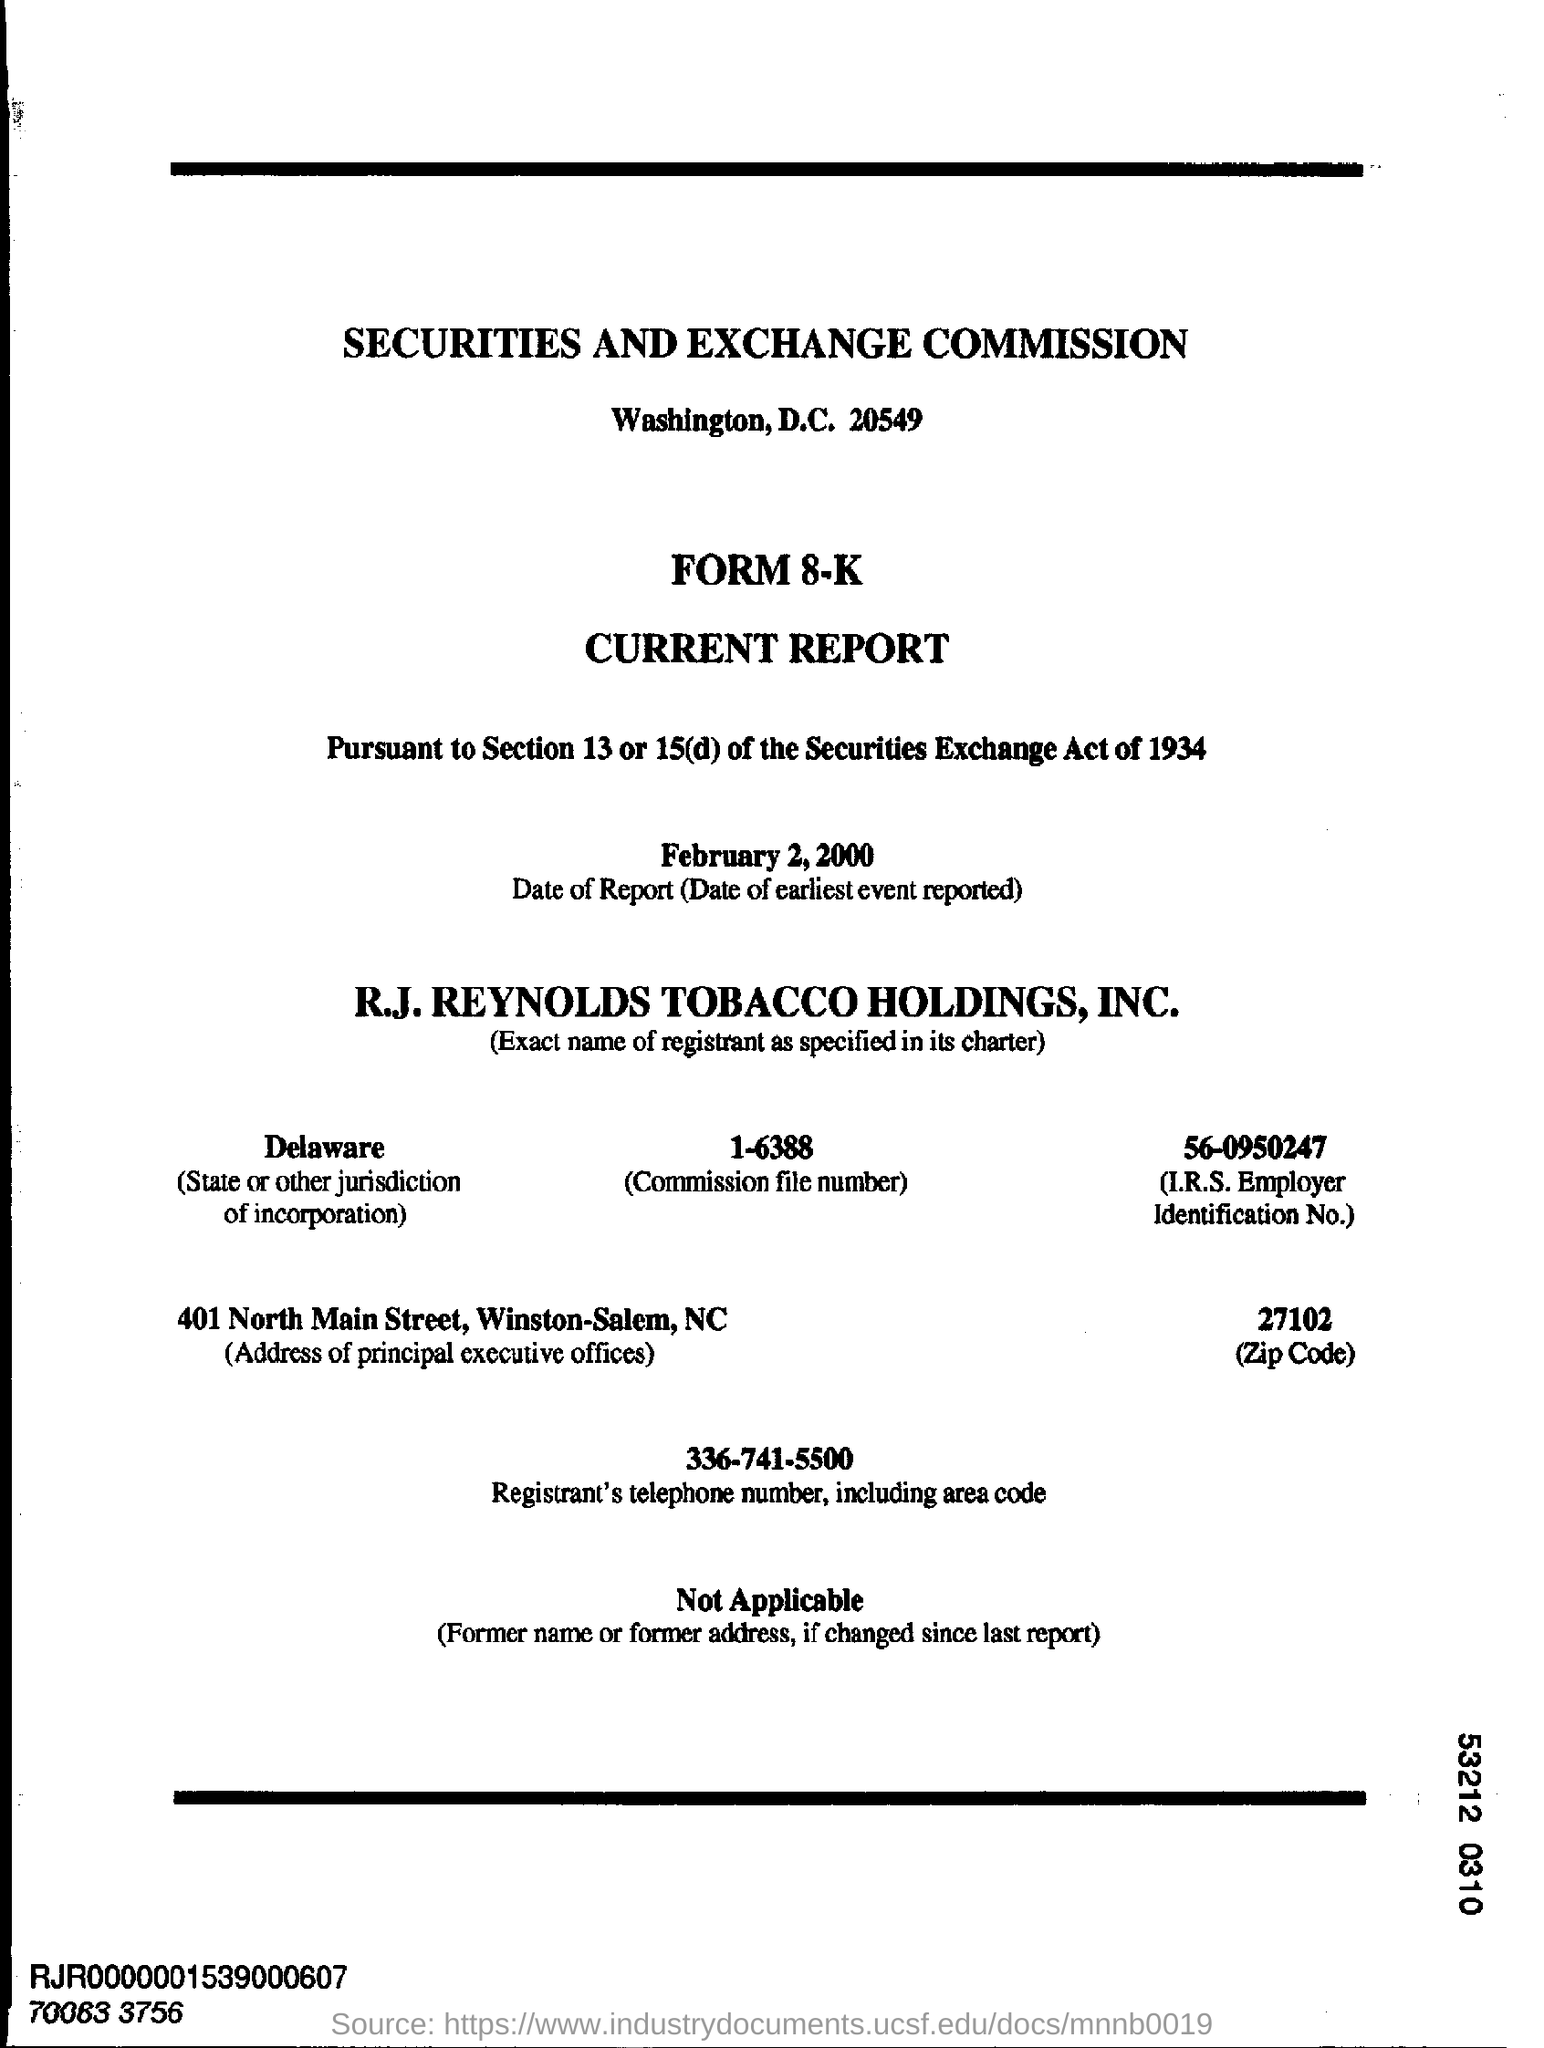What is the date of report (Date of earliest event reported)?
Your response must be concise. February 2, 2000. What is the Commission File No.?
Your answer should be very brief. 1-6388. 